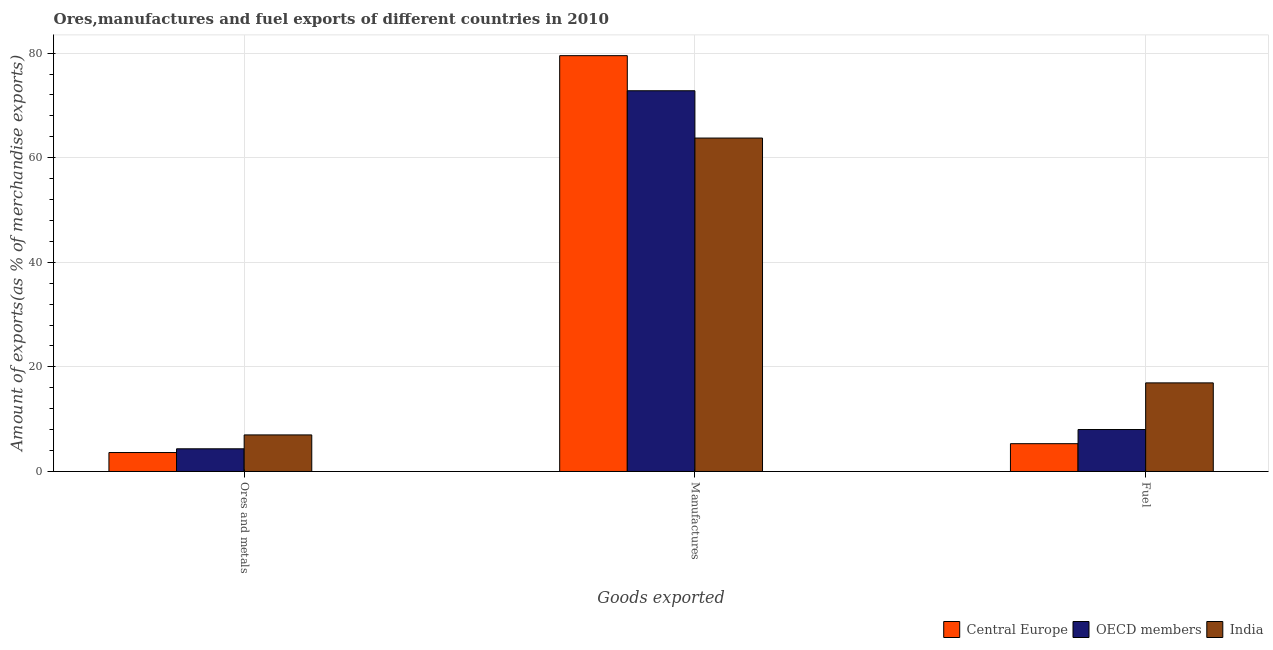Are the number of bars per tick equal to the number of legend labels?
Keep it short and to the point. Yes. Are the number of bars on each tick of the X-axis equal?
Offer a terse response. Yes. How many bars are there on the 2nd tick from the left?
Make the answer very short. 3. What is the label of the 1st group of bars from the left?
Keep it short and to the point. Ores and metals. What is the percentage of manufactures exports in Central Europe?
Offer a very short reply. 79.52. Across all countries, what is the maximum percentage of manufactures exports?
Ensure brevity in your answer.  79.52. Across all countries, what is the minimum percentage of ores and metals exports?
Make the answer very short. 3.62. In which country was the percentage of ores and metals exports maximum?
Your answer should be compact. India. In which country was the percentage of manufactures exports minimum?
Offer a very short reply. India. What is the total percentage of fuel exports in the graph?
Offer a very short reply. 30.29. What is the difference between the percentage of manufactures exports in OECD members and that in India?
Keep it short and to the point. 9.04. What is the difference between the percentage of fuel exports in India and the percentage of manufactures exports in Central Europe?
Provide a short and direct response. -62.57. What is the average percentage of ores and metals exports per country?
Offer a very short reply. 4.98. What is the difference between the percentage of ores and metals exports and percentage of manufactures exports in OECD members?
Make the answer very short. -68.47. What is the ratio of the percentage of ores and metals exports in OECD members to that in India?
Your answer should be very brief. 0.62. Is the percentage of fuel exports in India less than that in OECD members?
Provide a succinct answer. No. Is the difference between the percentage of ores and metals exports in India and OECD members greater than the difference between the percentage of fuel exports in India and OECD members?
Ensure brevity in your answer.  No. What is the difference between the highest and the second highest percentage of manufactures exports?
Your answer should be very brief. 6.71. What is the difference between the highest and the lowest percentage of ores and metals exports?
Your answer should be compact. 3.37. In how many countries, is the percentage of fuel exports greater than the average percentage of fuel exports taken over all countries?
Offer a very short reply. 1. Is the sum of the percentage of fuel exports in OECD members and India greater than the maximum percentage of manufactures exports across all countries?
Your response must be concise. No. What does the 1st bar from the left in Manufactures represents?
Keep it short and to the point. Central Europe. Is it the case that in every country, the sum of the percentage of ores and metals exports and percentage of manufactures exports is greater than the percentage of fuel exports?
Provide a succinct answer. Yes. How many bars are there?
Ensure brevity in your answer.  9. Are all the bars in the graph horizontal?
Keep it short and to the point. No. What is the difference between two consecutive major ticks on the Y-axis?
Ensure brevity in your answer.  20. Does the graph contain any zero values?
Ensure brevity in your answer.  No. How many legend labels are there?
Make the answer very short. 3. What is the title of the graph?
Provide a succinct answer. Ores,manufactures and fuel exports of different countries in 2010. What is the label or title of the X-axis?
Ensure brevity in your answer.  Goods exported. What is the label or title of the Y-axis?
Offer a terse response. Amount of exports(as % of merchandise exports). What is the Amount of exports(as % of merchandise exports) of Central Europe in Ores and metals?
Offer a very short reply. 3.62. What is the Amount of exports(as % of merchandise exports) of OECD members in Ores and metals?
Provide a short and direct response. 4.34. What is the Amount of exports(as % of merchandise exports) of India in Ores and metals?
Your answer should be compact. 6.99. What is the Amount of exports(as % of merchandise exports) of Central Europe in Manufactures?
Keep it short and to the point. 79.52. What is the Amount of exports(as % of merchandise exports) in OECD members in Manufactures?
Your response must be concise. 72.81. What is the Amount of exports(as % of merchandise exports) of India in Manufactures?
Make the answer very short. 63.76. What is the Amount of exports(as % of merchandise exports) of Central Europe in Fuel?
Your answer should be very brief. 5.32. What is the Amount of exports(as % of merchandise exports) in OECD members in Fuel?
Your answer should be very brief. 8.02. What is the Amount of exports(as % of merchandise exports) of India in Fuel?
Your answer should be compact. 16.95. Across all Goods exported, what is the maximum Amount of exports(as % of merchandise exports) of Central Europe?
Give a very brief answer. 79.52. Across all Goods exported, what is the maximum Amount of exports(as % of merchandise exports) of OECD members?
Keep it short and to the point. 72.81. Across all Goods exported, what is the maximum Amount of exports(as % of merchandise exports) of India?
Your answer should be compact. 63.76. Across all Goods exported, what is the minimum Amount of exports(as % of merchandise exports) in Central Europe?
Offer a terse response. 3.62. Across all Goods exported, what is the minimum Amount of exports(as % of merchandise exports) of OECD members?
Your answer should be very brief. 4.34. Across all Goods exported, what is the minimum Amount of exports(as % of merchandise exports) of India?
Offer a terse response. 6.99. What is the total Amount of exports(as % of merchandise exports) in Central Europe in the graph?
Make the answer very short. 88.46. What is the total Amount of exports(as % of merchandise exports) of OECD members in the graph?
Make the answer very short. 85.17. What is the total Amount of exports(as % of merchandise exports) of India in the graph?
Give a very brief answer. 87.7. What is the difference between the Amount of exports(as % of merchandise exports) of Central Europe in Ores and metals and that in Manufactures?
Provide a succinct answer. -75.9. What is the difference between the Amount of exports(as % of merchandise exports) of OECD members in Ores and metals and that in Manufactures?
Your response must be concise. -68.47. What is the difference between the Amount of exports(as % of merchandise exports) in India in Ores and metals and that in Manufactures?
Provide a succinct answer. -56.77. What is the difference between the Amount of exports(as % of merchandise exports) of Central Europe in Ores and metals and that in Fuel?
Your answer should be very brief. -1.7. What is the difference between the Amount of exports(as % of merchandise exports) in OECD members in Ores and metals and that in Fuel?
Offer a terse response. -3.69. What is the difference between the Amount of exports(as % of merchandise exports) in India in Ores and metals and that in Fuel?
Provide a succinct answer. -9.95. What is the difference between the Amount of exports(as % of merchandise exports) in Central Europe in Manufactures and that in Fuel?
Provide a succinct answer. 74.2. What is the difference between the Amount of exports(as % of merchandise exports) in OECD members in Manufactures and that in Fuel?
Provide a succinct answer. 64.78. What is the difference between the Amount of exports(as % of merchandise exports) of India in Manufactures and that in Fuel?
Make the answer very short. 46.82. What is the difference between the Amount of exports(as % of merchandise exports) in Central Europe in Ores and metals and the Amount of exports(as % of merchandise exports) in OECD members in Manufactures?
Ensure brevity in your answer.  -69.19. What is the difference between the Amount of exports(as % of merchandise exports) of Central Europe in Ores and metals and the Amount of exports(as % of merchandise exports) of India in Manufactures?
Your answer should be compact. -60.14. What is the difference between the Amount of exports(as % of merchandise exports) in OECD members in Ores and metals and the Amount of exports(as % of merchandise exports) in India in Manufactures?
Ensure brevity in your answer.  -59.43. What is the difference between the Amount of exports(as % of merchandise exports) in Central Europe in Ores and metals and the Amount of exports(as % of merchandise exports) in OECD members in Fuel?
Your answer should be very brief. -4.4. What is the difference between the Amount of exports(as % of merchandise exports) in Central Europe in Ores and metals and the Amount of exports(as % of merchandise exports) in India in Fuel?
Your answer should be compact. -13.32. What is the difference between the Amount of exports(as % of merchandise exports) in OECD members in Ores and metals and the Amount of exports(as % of merchandise exports) in India in Fuel?
Your answer should be compact. -12.61. What is the difference between the Amount of exports(as % of merchandise exports) of Central Europe in Manufactures and the Amount of exports(as % of merchandise exports) of OECD members in Fuel?
Give a very brief answer. 71.5. What is the difference between the Amount of exports(as % of merchandise exports) in Central Europe in Manufactures and the Amount of exports(as % of merchandise exports) in India in Fuel?
Your answer should be very brief. 62.57. What is the difference between the Amount of exports(as % of merchandise exports) in OECD members in Manufactures and the Amount of exports(as % of merchandise exports) in India in Fuel?
Your answer should be compact. 55.86. What is the average Amount of exports(as % of merchandise exports) of Central Europe per Goods exported?
Your answer should be very brief. 29.49. What is the average Amount of exports(as % of merchandise exports) in OECD members per Goods exported?
Make the answer very short. 28.39. What is the average Amount of exports(as % of merchandise exports) of India per Goods exported?
Make the answer very short. 29.23. What is the difference between the Amount of exports(as % of merchandise exports) in Central Europe and Amount of exports(as % of merchandise exports) in OECD members in Ores and metals?
Offer a very short reply. -0.72. What is the difference between the Amount of exports(as % of merchandise exports) in Central Europe and Amount of exports(as % of merchandise exports) in India in Ores and metals?
Ensure brevity in your answer.  -3.37. What is the difference between the Amount of exports(as % of merchandise exports) of OECD members and Amount of exports(as % of merchandise exports) of India in Ores and metals?
Provide a succinct answer. -2.66. What is the difference between the Amount of exports(as % of merchandise exports) of Central Europe and Amount of exports(as % of merchandise exports) of OECD members in Manufactures?
Your answer should be very brief. 6.71. What is the difference between the Amount of exports(as % of merchandise exports) in Central Europe and Amount of exports(as % of merchandise exports) in India in Manufactures?
Offer a very short reply. 15.76. What is the difference between the Amount of exports(as % of merchandise exports) in OECD members and Amount of exports(as % of merchandise exports) in India in Manufactures?
Your response must be concise. 9.04. What is the difference between the Amount of exports(as % of merchandise exports) in Central Europe and Amount of exports(as % of merchandise exports) in OECD members in Fuel?
Your answer should be compact. -2.71. What is the difference between the Amount of exports(as % of merchandise exports) of Central Europe and Amount of exports(as % of merchandise exports) of India in Fuel?
Ensure brevity in your answer.  -11.63. What is the difference between the Amount of exports(as % of merchandise exports) in OECD members and Amount of exports(as % of merchandise exports) in India in Fuel?
Your answer should be compact. -8.92. What is the ratio of the Amount of exports(as % of merchandise exports) in Central Europe in Ores and metals to that in Manufactures?
Offer a very short reply. 0.05. What is the ratio of the Amount of exports(as % of merchandise exports) in OECD members in Ores and metals to that in Manufactures?
Give a very brief answer. 0.06. What is the ratio of the Amount of exports(as % of merchandise exports) in India in Ores and metals to that in Manufactures?
Offer a terse response. 0.11. What is the ratio of the Amount of exports(as % of merchandise exports) of Central Europe in Ores and metals to that in Fuel?
Keep it short and to the point. 0.68. What is the ratio of the Amount of exports(as % of merchandise exports) of OECD members in Ores and metals to that in Fuel?
Ensure brevity in your answer.  0.54. What is the ratio of the Amount of exports(as % of merchandise exports) in India in Ores and metals to that in Fuel?
Provide a short and direct response. 0.41. What is the ratio of the Amount of exports(as % of merchandise exports) of Central Europe in Manufactures to that in Fuel?
Provide a short and direct response. 14.95. What is the ratio of the Amount of exports(as % of merchandise exports) of OECD members in Manufactures to that in Fuel?
Your response must be concise. 9.07. What is the ratio of the Amount of exports(as % of merchandise exports) of India in Manufactures to that in Fuel?
Make the answer very short. 3.76. What is the difference between the highest and the second highest Amount of exports(as % of merchandise exports) in Central Europe?
Your answer should be very brief. 74.2. What is the difference between the highest and the second highest Amount of exports(as % of merchandise exports) in OECD members?
Ensure brevity in your answer.  64.78. What is the difference between the highest and the second highest Amount of exports(as % of merchandise exports) in India?
Give a very brief answer. 46.82. What is the difference between the highest and the lowest Amount of exports(as % of merchandise exports) of Central Europe?
Offer a terse response. 75.9. What is the difference between the highest and the lowest Amount of exports(as % of merchandise exports) of OECD members?
Your answer should be compact. 68.47. What is the difference between the highest and the lowest Amount of exports(as % of merchandise exports) of India?
Your response must be concise. 56.77. 